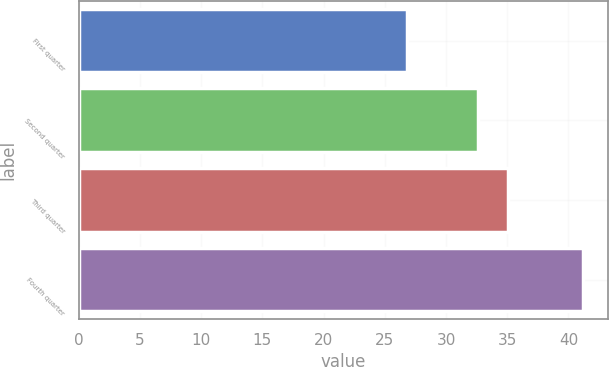<chart> <loc_0><loc_0><loc_500><loc_500><bar_chart><fcel>First quarter<fcel>Second quarter<fcel>Third quarter<fcel>Fourth quarter<nl><fcel>26.82<fcel>32.64<fcel>35.03<fcel>41.17<nl></chart> 